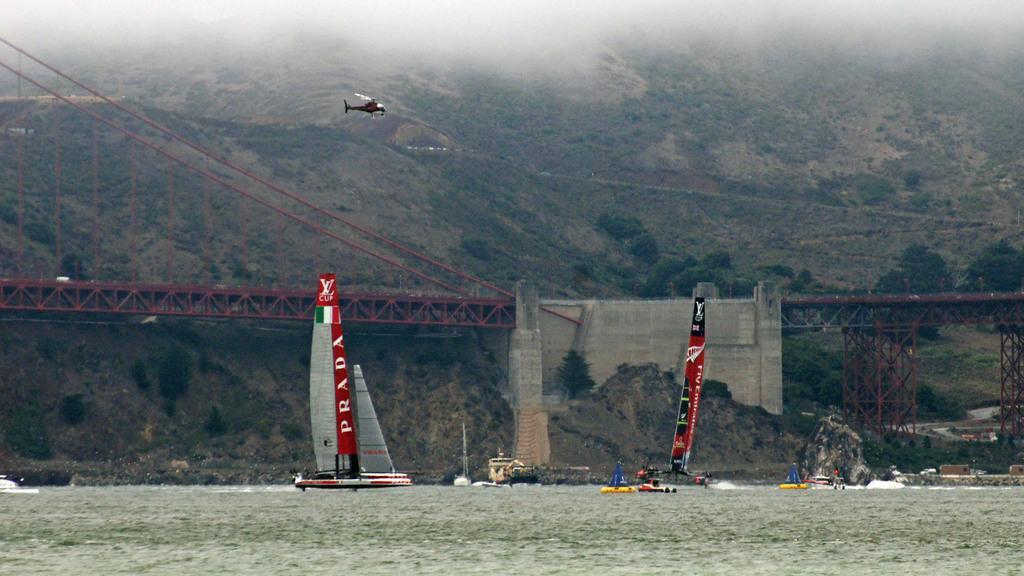Please provide a concise description of this image. In this picture we can see a group of boats on water and in the background we can see an airplane,trees,bridge. 